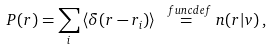<formula> <loc_0><loc_0><loc_500><loc_500>P ( r ) = \sum _ { i } \, \langle \delta ( r - r _ { i } ) \rangle \overset { \ f u n c { d e f } } { = } n ( r | v ) \, ,</formula> 